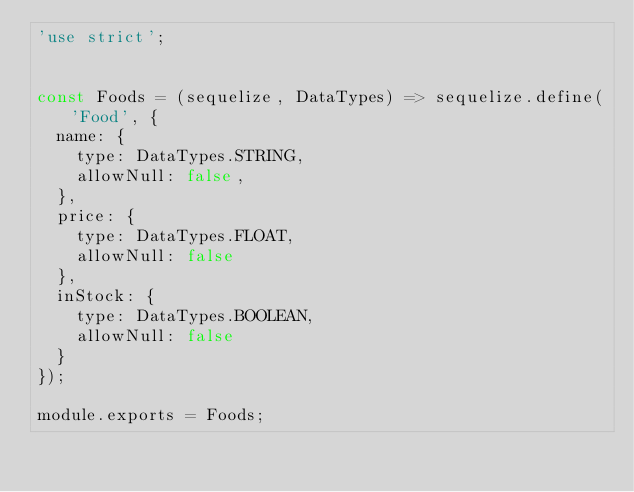<code> <loc_0><loc_0><loc_500><loc_500><_JavaScript_>'use strict';


const Foods = (sequelize, DataTypes) => sequelize.define('Food', {
  name: {
    type: DataTypes.STRING,
    allowNull: false,
  },
  price: {
    type: DataTypes.FLOAT,
    allowNull: false
  },
  inStock: {
    type: DataTypes.BOOLEAN,
    allowNull: false
  }
});

module.exports = Foods;</code> 